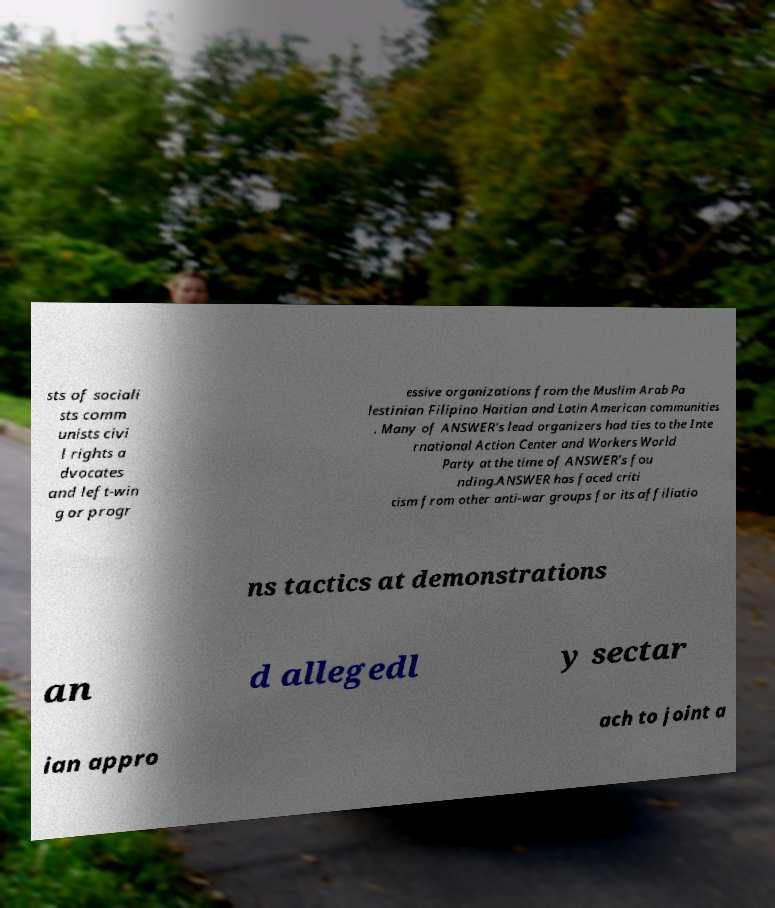What messages or text are displayed in this image? I need them in a readable, typed format. sts of sociali sts comm unists civi l rights a dvocates and left-win g or progr essive organizations from the Muslim Arab Pa lestinian Filipino Haitian and Latin American communities . Many of ANSWER's lead organizers had ties to the Inte rnational Action Center and Workers World Party at the time of ANSWER's fou nding.ANSWER has faced criti cism from other anti-war groups for its affiliatio ns tactics at demonstrations an d allegedl y sectar ian appro ach to joint a 